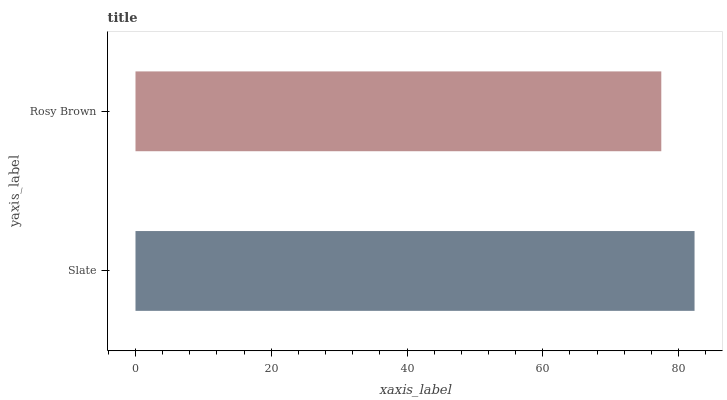Is Rosy Brown the minimum?
Answer yes or no. Yes. Is Slate the maximum?
Answer yes or no. Yes. Is Rosy Brown the maximum?
Answer yes or no. No. Is Slate greater than Rosy Brown?
Answer yes or no. Yes. Is Rosy Brown less than Slate?
Answer yes or no. Yes. Is Rosy Brown greater than Slate?
Answer yes or no. No. Is Slate less than Rosy Brown?
Answer yes or no. No. Is Slate the high median?
Answer yes or no. Yes. Is Rosy Brown the low median?
Answer yes or no. Yes. Is Rosy Brown the high median?
Answer yes or no. No. Is Slate the low median?
Answer yes or no. No. 